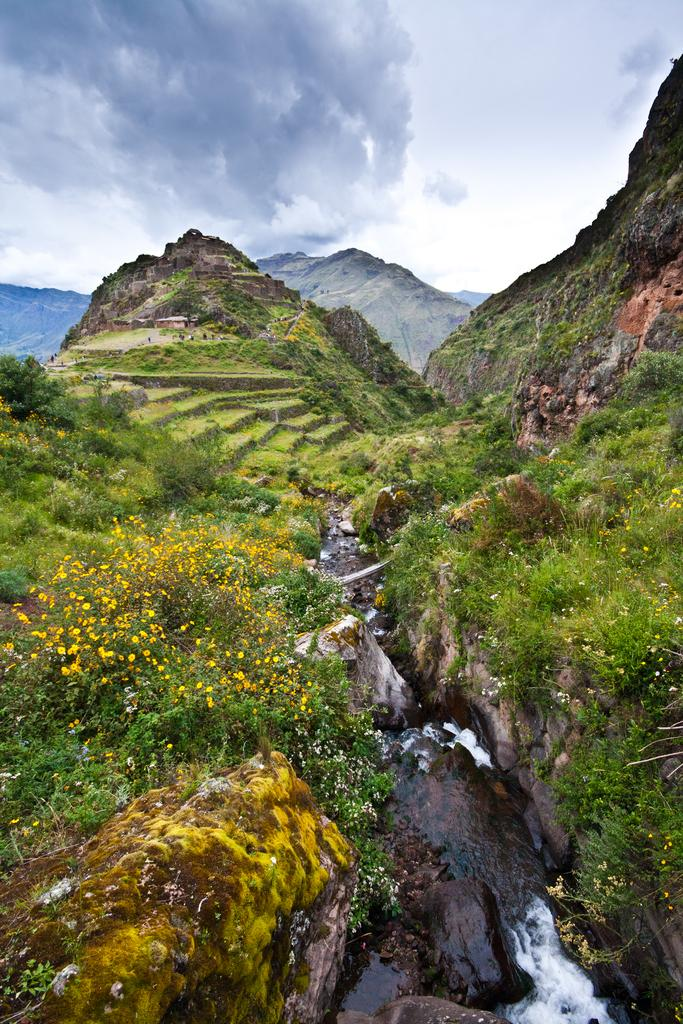What type of living organisms can be seen in the image? Plants, grass, and flowers are visible in the image. What natural element is present in the image? Water is visible in the image. What geographical feature can be seen in the image? There are mountains in the image. What is the condition of the sky in the image? The sky is cloudy in the image. What type of argument can be seen taking place in the image? There is no argument present in the image; it features natural elements and geographical features. What type of stew is being prepared in the image? There is no stew being prepared in the image; it features plants, grass, flowers, water, mountains, and a cloudy sky. 